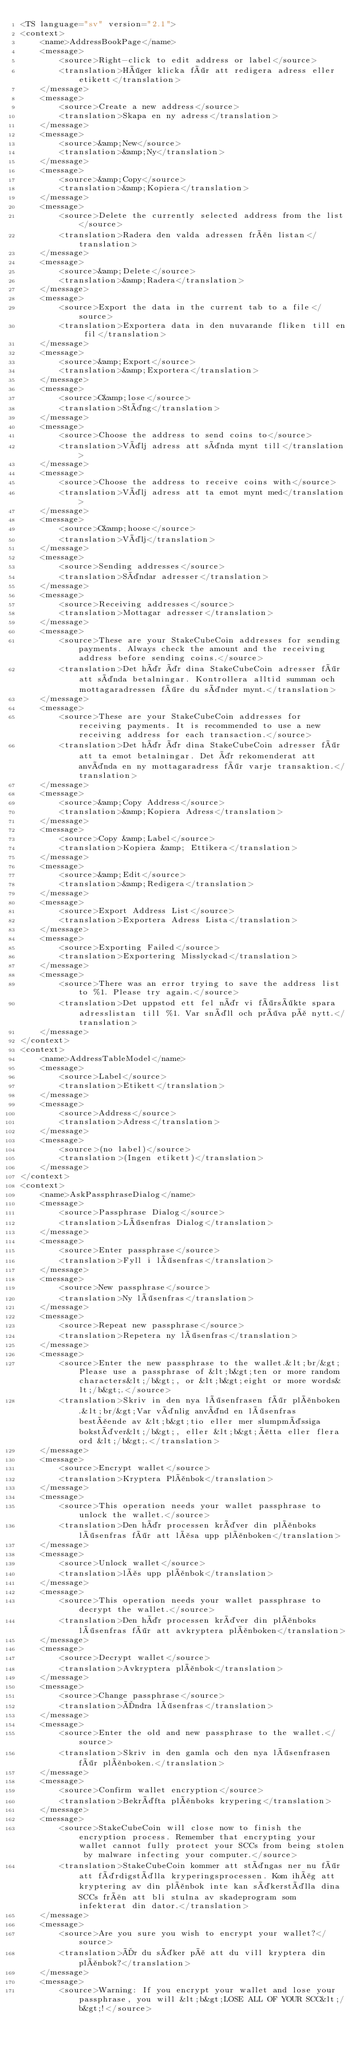<code> <loc_0><loc_0><loc_500><loc_500><_TypeScript_><TS language="sv" version="2.1">
<context>
    <name>AddressBookPage</name>
    <message>
        <source>Right-click to edit address or label</source>
        <translation>Höger klicka för att redigera adress eller etikett</translation>
    </message>
    <message>
        <source>Create a new address</source>
        <translation>Skapa en ny adress</translation>
    </message>
    <message>
        <source>&amp;New</source>
        <translation>&amp;Ny</translation>
    </message>
    <message>
        <source>&amp;Copy</source>
        <translation>&amp;Kopiera</translation>
    </message>
    <message>
        <source>Delete the currently selected address from the list</source>
        <translation>Radera den valda adressen från listan</translation>
    </message>
    <message>
        <source>&amp;Delete</source>
        <translation>&amp;Radera</translation>
    </message>
    <message>
        <source>Export the data in the current tab to a file</source>
        <translation>Exportera data in den nuvarande fliken till en fil</translation>
    </message>
    <message>
        <source>&amp;Export</source>
        <translation>&amp;Exportera</translation>
    </message>
    <message>
        <source>C&amp;lose</source>
        <translation>Stäng</translation>
    </message>
    <message>
        <source>Choose the address to send coins to</source>
        <translation>Välj adress att sända mynt till</translation>
    </message>
    <message>
        <source>Choose the address to receive coins with</source>
        <translation>Välj adress att ta emot mynt med</translation>
    </message>
    <message>
        <source>C&amp;hoose</source>
        <translation>Välj</translation>
    </message>
    <message>
        <source>Sending addresses</source>
        <translation>Sändar adresser</translation>
    </message>
    <message>
        <source>Receiving addresses</source>
        <translation>Mottagar adresser</translation>
    </message>
    <message>
        <source>These are your StakeCubeCoin addresses for sending payments. Always check the amount and the receiving address before sending coins.</source>
        <translation>Det här är dina StakeCubeCoin adresser för att sända betalningar. Kontrollera alltid summan och mottagaradressen före du sänder mynt.</translation>
    </message>
    <message>
        <source>These are your StakeCubeCoin addresses for receiving payments. It is recommended to use a new receiving address for each transaction.</source>
        <translation>Det här är dina StakeCubeCoin adresser för att ta emot betalningar. Det är rekomenderat att använda en ny mottagaradress för varje transaktion.</translation>
    </message>
    <message>
        <source>&amp;Copy Address</source>
        <translation>&amp;Kopiera Adress</translation>
    </message>
    <message>
        <source>Copy &amp;Label</source>
        <translation>Kopiera &amp; Ettikera</translation>
    </message>
    <message>
        <source>&amp;Edit</source>
        <translation>&amp;Redigera</translation>
    </message>
    <message>
        <source>Export Address List</source>
        <translation>Exportera Adress Lista</translation>
    </message>
    <message>
        <source>Exporting Failed</source>
        <translation>Exportering Misslyckad</translation>
    </message>
    <message>
        <source>There was an error trying to save the address list to %1. Please try again.</source>
        <translation>Det uppstod ett fel när vi försökte spara adresslistan till %1. Var snäll och pröva på nytt.</translation>
    </message>
</context>
<context>
    <name>AddressTableModel</name>
    <message>
        <source>Label</source>
        <translation>Etikett</translation>
    </message>
    <message>
        <source>Address</source>
        <translation>Adress</translation>
    </message>
    <message>
        <source>(no label)</source>
        <translation>(Ingen etikett)</translation>
    </message>
</context>
<context>
    <name>AskPassphraseDialog</name>
    <message>
        <source>Passphrase Dialog</source>
        <translation>Lösenfras Dialog</translation>
    </message>
    <message>
        <source>Enter passphrase</source>
        <translation>Fyll i lösenfras</translation>
    </message>
    <message>
        <source>New passphrase</source>
        <translation>Ny lösenfras</translation>
    </message>
    <message>
        <source>Repeat new passphrase</source>
        <translation>Repetera ny lösenfras</translation>
    </message>
    <message>
        <source>Enter the new passphrase to the wallet.&lt;br/&gt;Please use a passphrase of &lt;b&gt;ten or more random characters&lt;/b&gt;, or &lt;b&gt;eight or more words&lt;/b&gt;.</source>
        <translation>Skriv in den nya lösenfrasen för plånboken.&lt;br/&gt;Var vänlig använd en lösenfras bestående av &lt;b&gt;tio eller mer slumpmässiga bokstäver&lt;/b&gt;, eller &lt;b&gt;åtta eller flera ord &lt;/b&gt;.</translation>
    </message>
    <message>
        <source>Encrypt wallet</source>
        <translation>Kryptera Plånbok</translation>
    </message>
    <message>
        <source>This operation needs your wallet passphrase to unlock the wallet.</source>
        <translation>Den här processen kräver din plånboks lösenfras för att låsa upp plånboken</translation>
    </message>
    <message>
        <source>Unlock wallet</source>
        <translation>lås upp plånbok</translation>
    </message>
    <message>
        <source>This operation needs your wallet passphrase to decrypt the wallet.</source>
        <translation>Den här processen kräver din plånboks lösenfras för att avkryptera plånboken</translation>
    </message>
    <message>
        <source>Decrypt wallet</source>
        <translation>Avkryptera plånbok</translation>
    </message>
    <message>
        <source>Change passphrase</source>
        <translation>Ändra lösenfras</translation>
    </message>
    <message>
        <source>Enter the old and new passphrase to the wallet.</source>
        <translation>Skriv in den gamla och den nya lösenfrasen för plånboken.</translation>
    </message>
    <message>
        <source>Confirm wallet encryption</source>
        <translation>Bekräfta plånboks krypering</translation>
    </message>
    <message>
        <source>StakeCubeCoin will close now to finish the encryption process. Remember that encrypting your wallet cannot fully protect your SCCs from being stolen by malware infecting your computer.</source>
        <translation>StakeCubeCoin kommer att stängas ner nu för att färdigställa kryperingsprocessen. Kom ihåg att kryptering av din plånbok inte kan säkerställa dina SCCs från att bli stulna av skadeprogram som infekterat din dator.</translation>
    </message>
    <message>
        <source>Are you sure you wish to encrypt your wallet?</source>
        <translation>Är du säker på att du vill kryptera din plånbok?</translation>
    </message>
    <message>
        <source>Warning: If you encrypt your wallet and lose your passphrase, you will &lt;b&gt;LOSE ALL OF YOUR SCC&lt;/b&gt;!</source></code> 